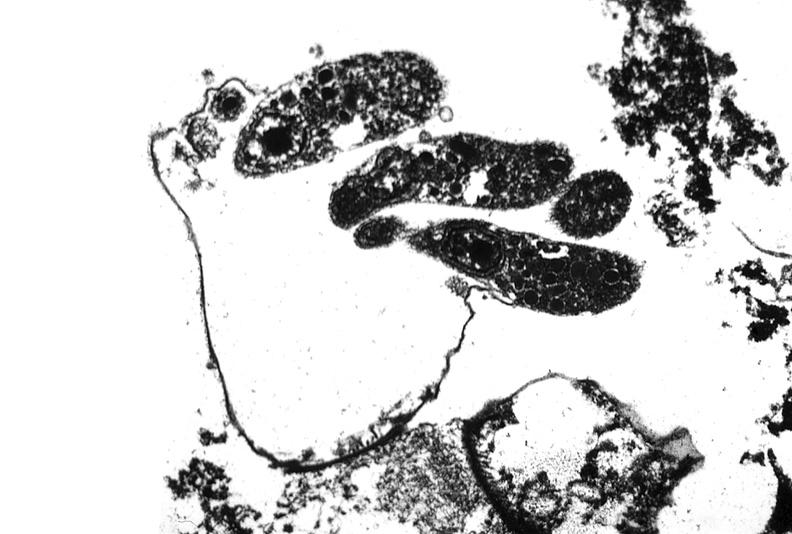where is this electron microscopy figure taken?
Answer the question using a single word or phrase. Gastrointestinal system 